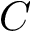Convert formula to latex. <formula><loc_0><loc_0><loc_500><loc_500>C</formula> 